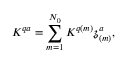Convert formula to latex. <formula><loc_0><loc_0><loc_500><loc_500>K ^ { q a } = \sum _ { m = 1 } ^ { N _ { 0 } } K ^ { q ( m ) } \mathfrak { z } _ { ( m ) } ^ { a } ,</formula> 